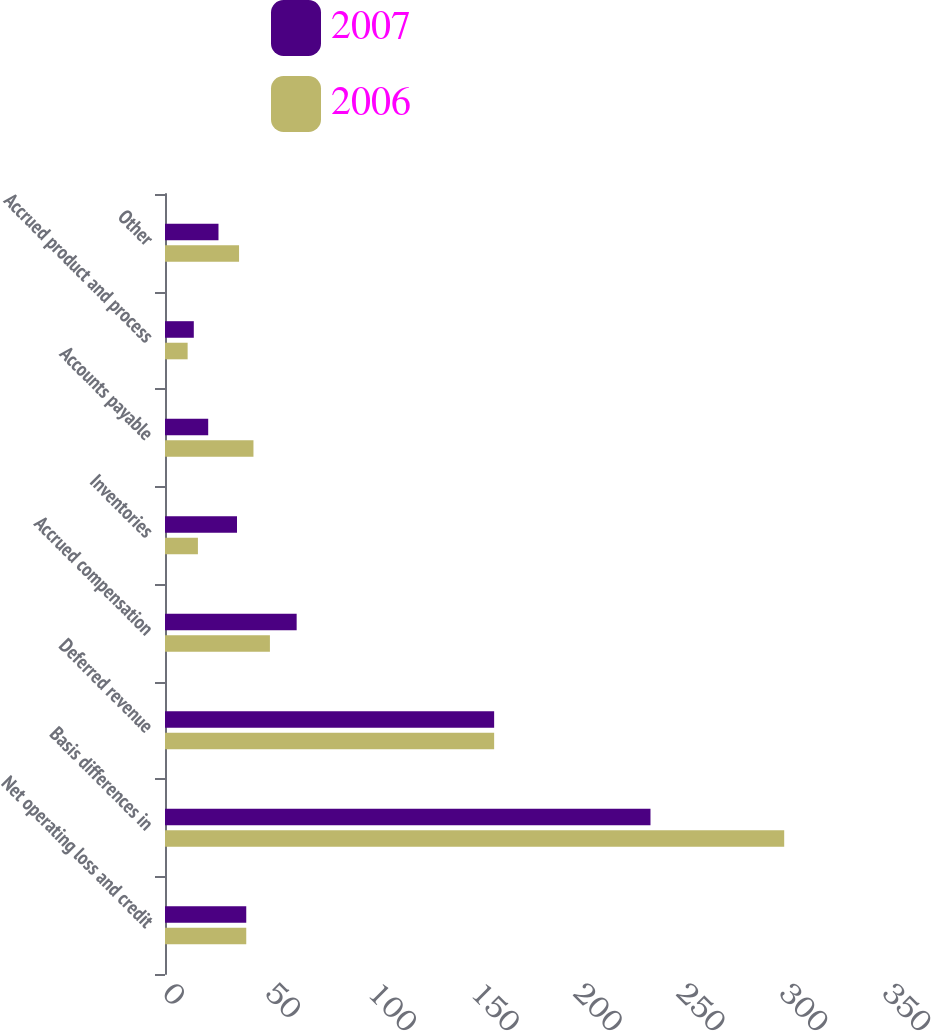Convert chart to OTSL. <chart><loc_0><loc_0><loc_500><loc_500><stacked_bar_chart><ecel><fcel>Net operating loss and credit<fcel>Basis differences in<fcel>Deferred revenue<fcel>Accrued compensation<fcel>Inventories<fcel>Accounts payable<fcel>Accrued product and process<fcel>Other<nl><fcel>2007<fcel>39.5<fcel>236<fcel>160<fcel>64<fcel>35<fcel>21<fcel>14<fcel>26<nl><fcel>2006<fcel>39.5<fcel>301<fcel>160<fcel>51<fcel>16<fcel>43<fcel>11<fcel>36<nl></chart> 